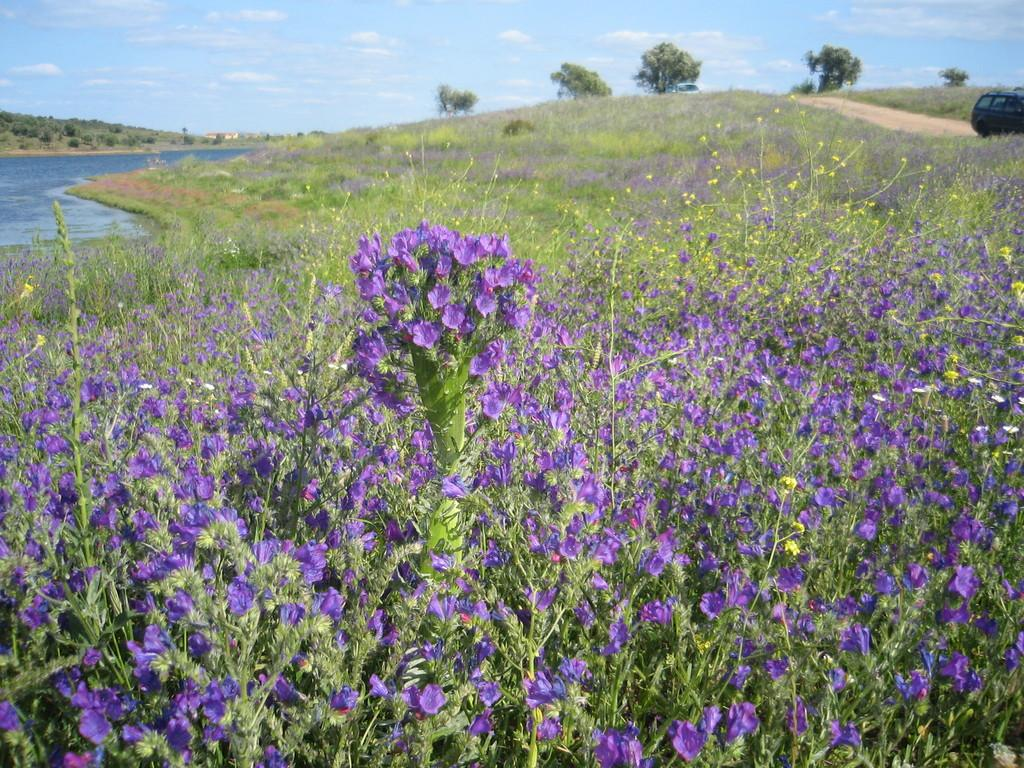What type of vegetation can be seen in the image? There are flowers on plants in the plants in the image. What natural feature is visible in the background of the image? There is a river in the background of the image. What other type of vegetation can be seen in the background of the image? There are trees in the background of the image. What type of creature is using a brush to paint the river in the image? There is no creature or brush present in the image; it features flowers on plants, a river, and trees in the background. 